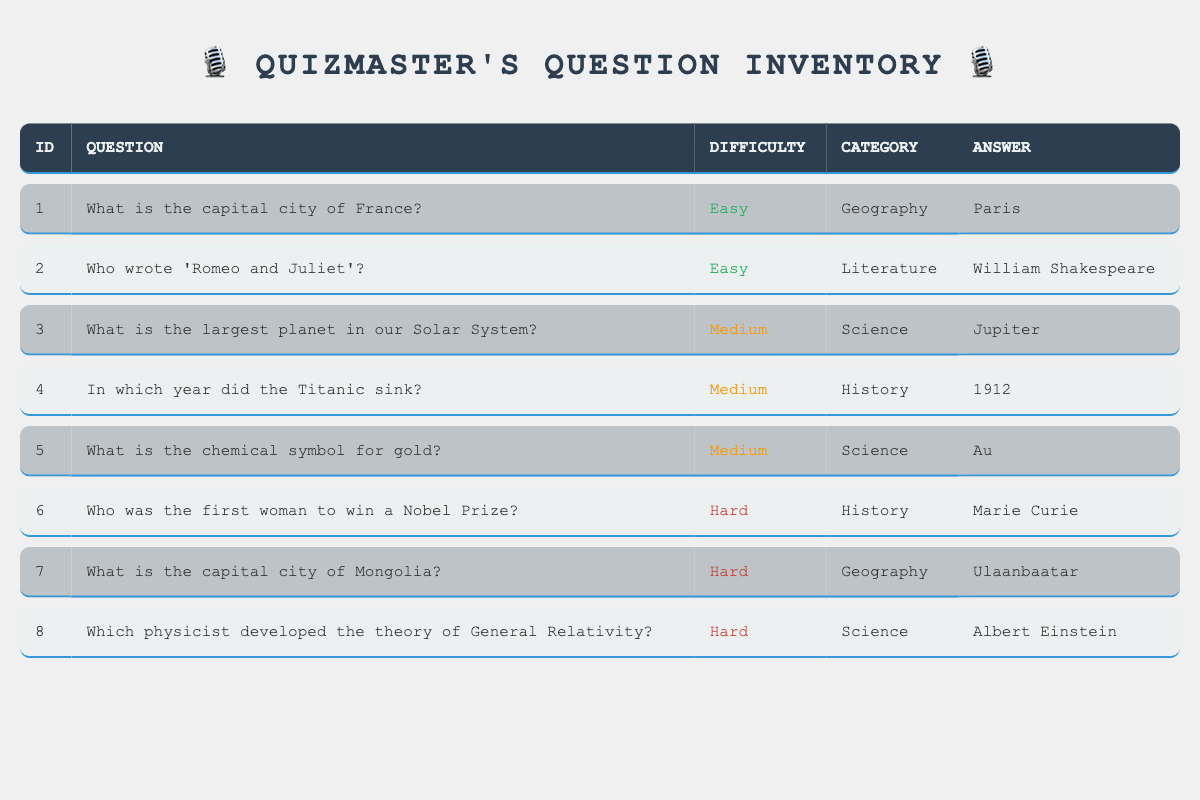What is the answer to the question with ID 1? The question with ID 1 is "What is the capital city of France?" and the answer provided in the table is "Paris."
Answer: Paris How many questions are classified as "Medium" difficulty? By examining the table, there are three questions classified as "Medium" difficulty. They are IDs 3, 4, and 5.
Answer: 3 Is "Ulaanbaatar" the capital of any country according to the table? The table indicates that "Ulaanbaatar" is the answer to the question "What is the capital city of Mongolia?" Therefore, it is indeed the capital of a country.
Answer: Yes Which category has the most questions, based on the table? The table presents three categories: Geography, Literature, Science, and History. Geography has 2 questions, Literature has 1, Science has 3, and History has 2. Since Science has the highest count, it is the category with the most questions.
Answer: Science What is the sum of question IDs for "Hard" difficulty questions? The question IDs for "Hard" difficulty are 6, 7, and 8. Adding these gives us 6 + 7 + 8 = 21.
Answer: 21 